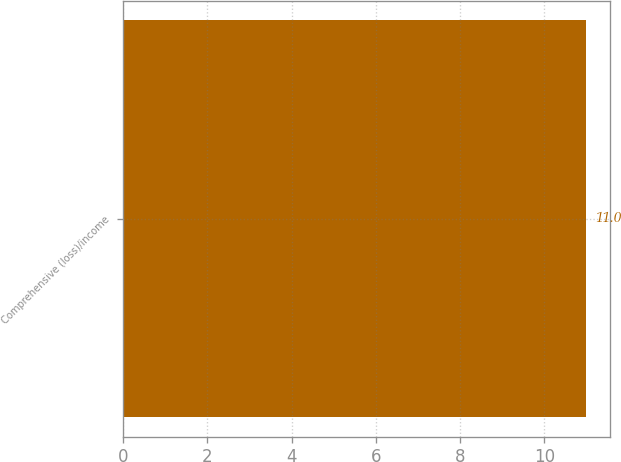<chart> <loc_0><loc_0><loc_500><loc_500><bar_chart><fcel>Comprehensive (loss)/income<nl><fcel>11<nl></chart> 